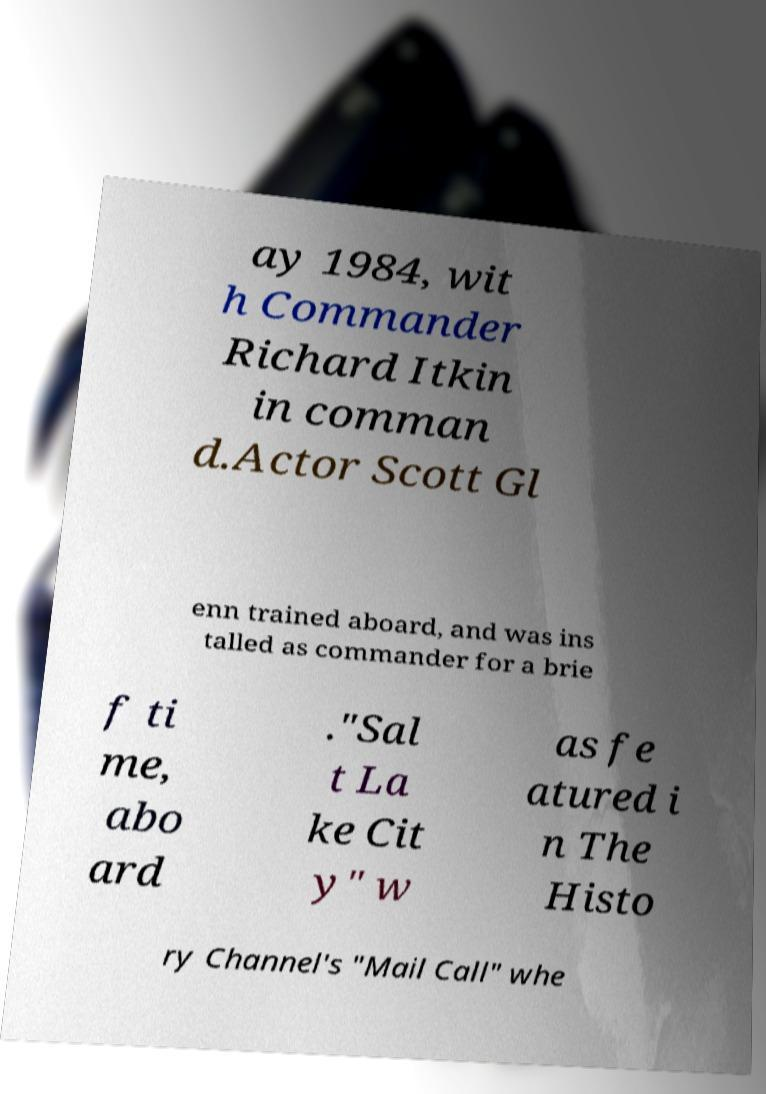I need the written content from this picture converted into text. Can you do that? ay 1984, wit h Commander Richard Itkin in comman d.Actor Scott Gl enn trained aboard, and was ins talled as commander for a brie f ti me, abo ard ."Sal t La ke Cit y" w as fe atured i n The Histo ry Channel's "Mail Call" whe 